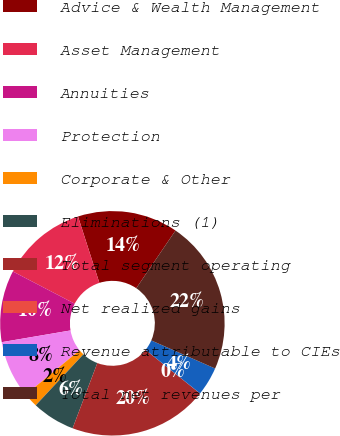Convert chart. <chart><loc_0><loc_0><loc_500><loc_500><pie_chart><fcel>Advice & Wealth Management<fcel>Asset Management<fcel>Annuities<fcel>Protection<fcel>Corporate & Other<fcel>Eliminations (1)<fcel>Total segment operating<fcel>Net realized gains<fcel>Revenue attributable to CIEs<fcel>Total net revenues per<nl><fcel>14.46%<fcel>12.4%<fcel>10.33%<fcel>8.27%<fcel>2.08%<fcel>6.2%<fcel>20.02%<fcel>0.01%<fcel>4.14%<fcel>22.09%<nl></chart> 